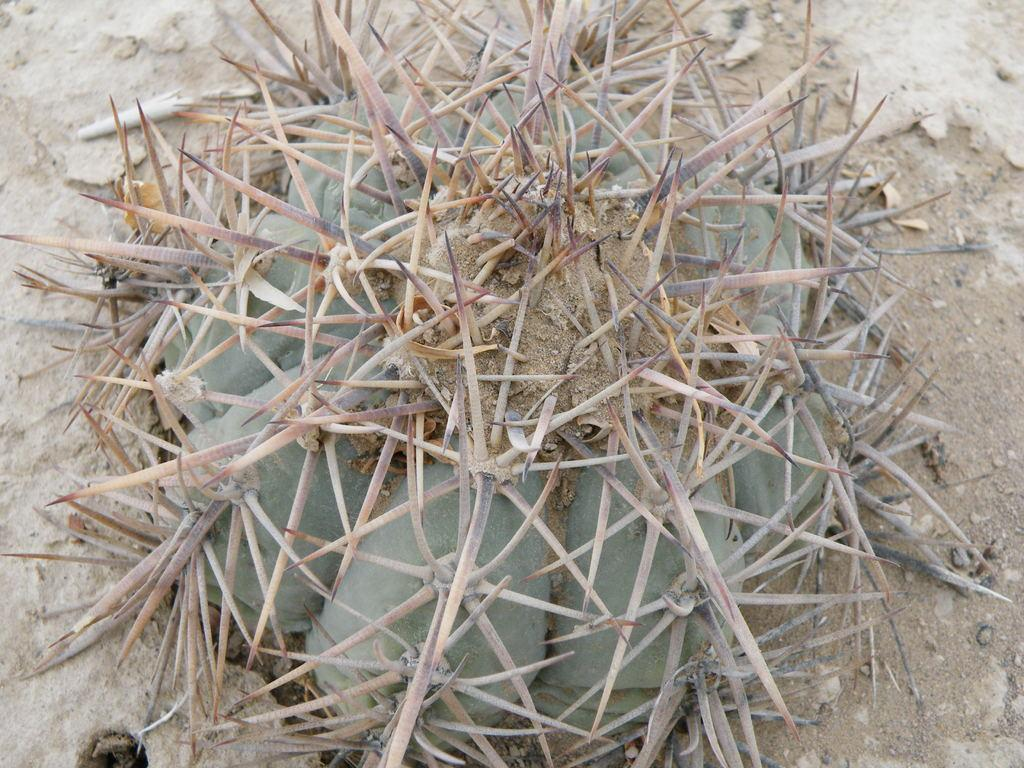What type of living organism can be seen in the image? There is a plant in the image. What part of the natural environment is visible in the image? The sky is visible in the image. What type of trail can be seen in the image? There is no trail present in the image. How many beds are visible in the image? There are no beds present in the image. What type of shaking activity is happening in the image? There is no shaking activity present in the image. 